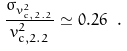<formula> <loc_0><loc_0><loc_500><loc_500>\frac { \sigma _ { v _ { c , 2 . 2 } ^ { 2 } } } { v _ { c , 2 . 2 } ^ { 2 } } \simeq 0 . 2 6 \ .</formula> 